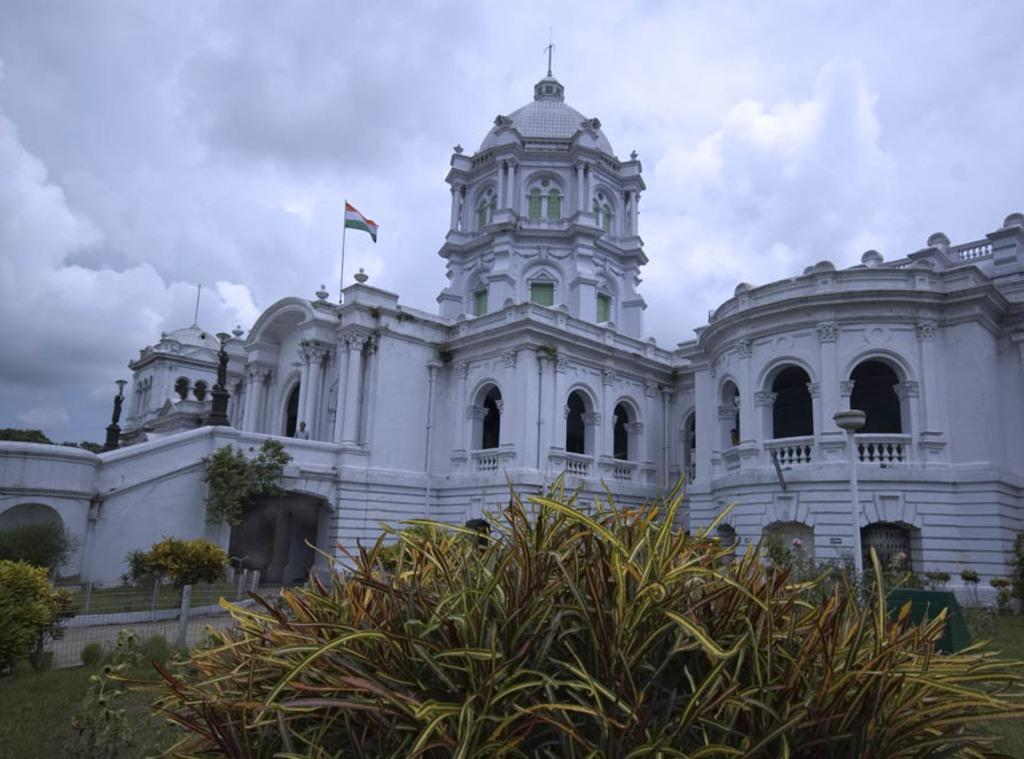What type of vegetation can be seen in the image? There is grass and plants in the image. What structures are present in the image? There are fences, a path, a building, and statues in the image. What additional objects can be seen in the image? There is a flag and some other objects in the image. What is visible in the background of the image? The sky is visible in the background of the image. What can be observed in the sky? There are clouds in the sky. What is the rate of the club spinning in the image? There is no club present in the image, so it is not possible to determine the rate of any spinning object. What type of glass can be seen in the image? There is no glass present in the image; it features grass, plants, fences, a path, a building, a flag, statues, and other objects. 